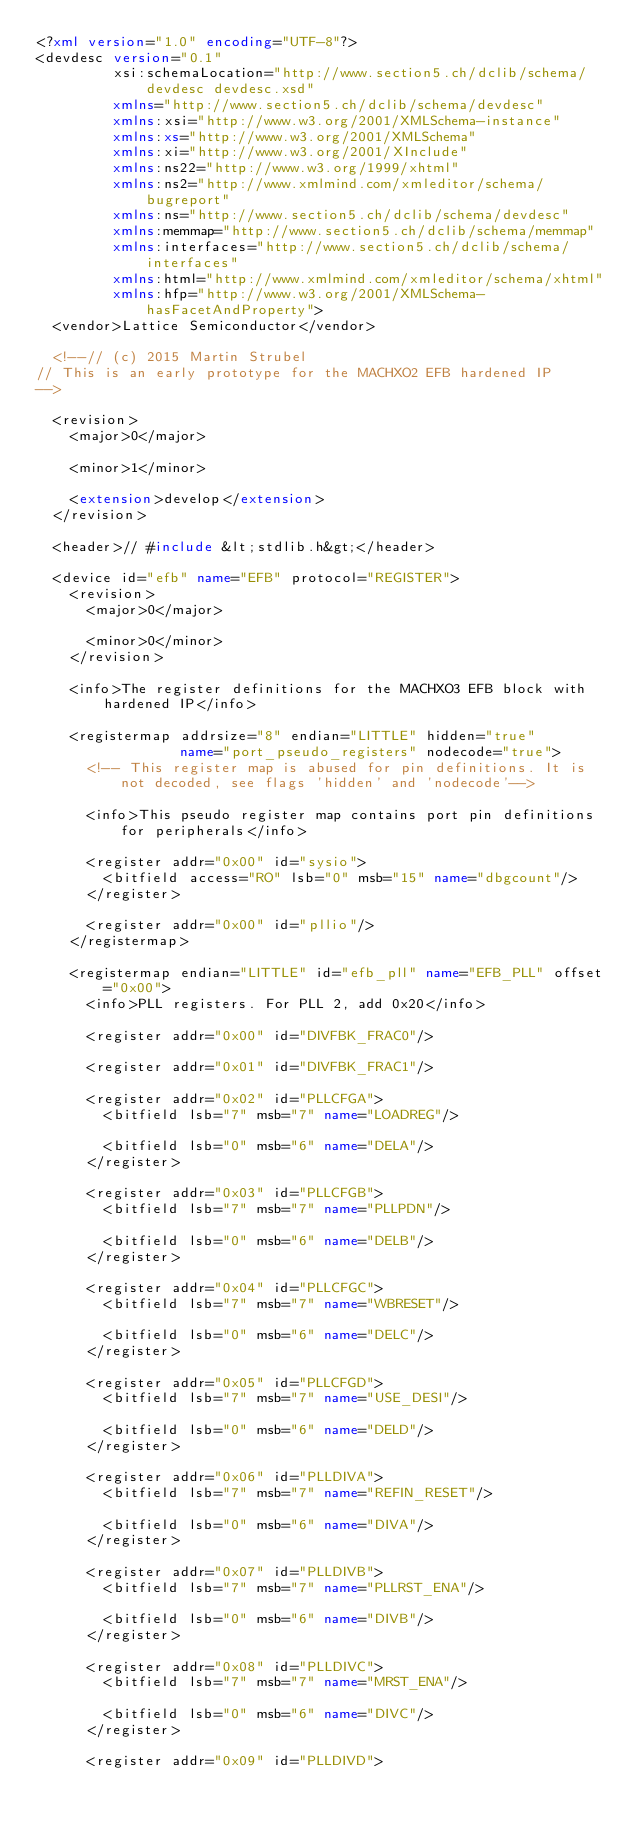Convert code to text. <code><loc_0><loc_0><loc_500><loc_500><_XML_><?xml version="1.0" encoding="UTF-8"?>
<devdesc version="0.1"
         xsi:schemaLocation="http://www.section5.ch/dclib/schema/devdesc devdesc.xsd"
         xmlns="http://www.section5.ch/dclib/schema/devdesc"
         xmlns:xsi="http://www.w3.org/2001/XMLSchema-instance"
         xmlns:xs="http://www.w3.org/2001/XMLSchema"
         xmlns:xi="http://www.w3.org/2001/XInclude"
         xmlns:ns22="http://www.w3.org/1999/xhtml"
         xmlns:ns2="http://www.xmlmind.com/xmleditor/schema/bugreport"
         xmlns:ns="http://www.section5.ch/dclib/schema/devdesc"
         xmlns:memmap="http://www.section5.ch/dclib/schema/memmap"
         xmlns:interfaces="http://www.section5.ch/dclib/schema/interfaces"
         xmlns:html="http://www.xmlmind.com/xmleditor/schema/xhtml"
         xmlns:hfp="http://www.w3.org/2001/XMLSchema-hasFacetAndProperty">
  <vendor>Lattice Semiconductor</vendor>

  <!--// (c) 2015 Martin Strubel
// This is an early prototype for the MACHXO2 EFB hardened IP
-->

  <revision>
    <major>0</major>

    <minor>1</minor>

    <extension>develop</extension>
  </revision>

  <header>// #include &lt;stdlib.h&gt;</header>

  <device id="efb" name="EFB" protocol="REGISTER">
    <revision>
      <major>0</major>

      <minor>0</minor>
    </revision>

    <info>The register definitions for the MACHXO3 EFB block with hardened IP</info>

    <registermap addrsize="8" endian="LITTLE" hidden="true"
                 name="port_pseudo_registers" nodecode="true">
      <!-- This register map is abused for pin definitions. It is not decoded, see flags 'hidden' and 'nodecode'-->

      <info>This pseudo register map contains port pin definitions for peripherals</info>

      <register addr="0x00" id="sysio">
        <bitfield access="RO" lsb="0" msb="15" name="dbgcount"/>
      </register>

      <register addr="0x00" id="pllio"/>
    </registermap>

    <registermap endian="LITTLE" id="efb_pll" name="EFB_PLL" offset="0x00">
      <info>PLL registers. For PLL 2, add 0x20</info>

      <register addr="0x00" id="DIVFBK_FRAC0"/>

      <register addr="0x01" id="DIVFBK_FRAC1"/>

      <register addr="0x02" id="PLLCFGA">
        <bitfield lsb="7" msb="7" name="LOADREG"/>

        <bitfield lsb="0" msb="6" name="DELA"/>
      </register>

      <register addr="0x03" id="PLLCFGB">
        <bitfield lsb="7" msb="7" name="PLLPDN"/>

        <bitfield lsb="0" msb="6" name="DELB"/>
      </register>

      <register addr="0x04" id="PLLCFGC">
        <bitfield lsb="7" msb="7" name="WBRESET"/>

        <bitfield lsb="0" msb="6" name="DELC"/>
      </register>

      <register addr="0x05" id="PLLCFGD">
        <bitfield lsb="7" msb="7" name="USE_DESI"/>

        <bitfield lsb="0" msb="6" name="DELD"/>
      </register>

      <register addr="0x06" id="PLLDIVA">
        <bitfield lsb="7" msb="7" name="REFIN_RESET"/>

        <bitfield lsb="0" msb="6" name="DIVA"/>
      </register>

      <register addr="0x07" id="PLLDIVB">
        <bitfield lsb="7" msb="7" name="PLLRST_ENA"/>

        <bitfield lsb="0" msb="6" name="DIVB"/>
      </register>

      <register addr="0x08" id="PLLDIVC">
        <bitfield lsb="7" msb="7" name="MRST_ENA"/>

        <bitfield lsb="0" msb="6" name="DIVC"/>
      </register>

      <register addr="0x09" id="PLLDIVD"></code> 